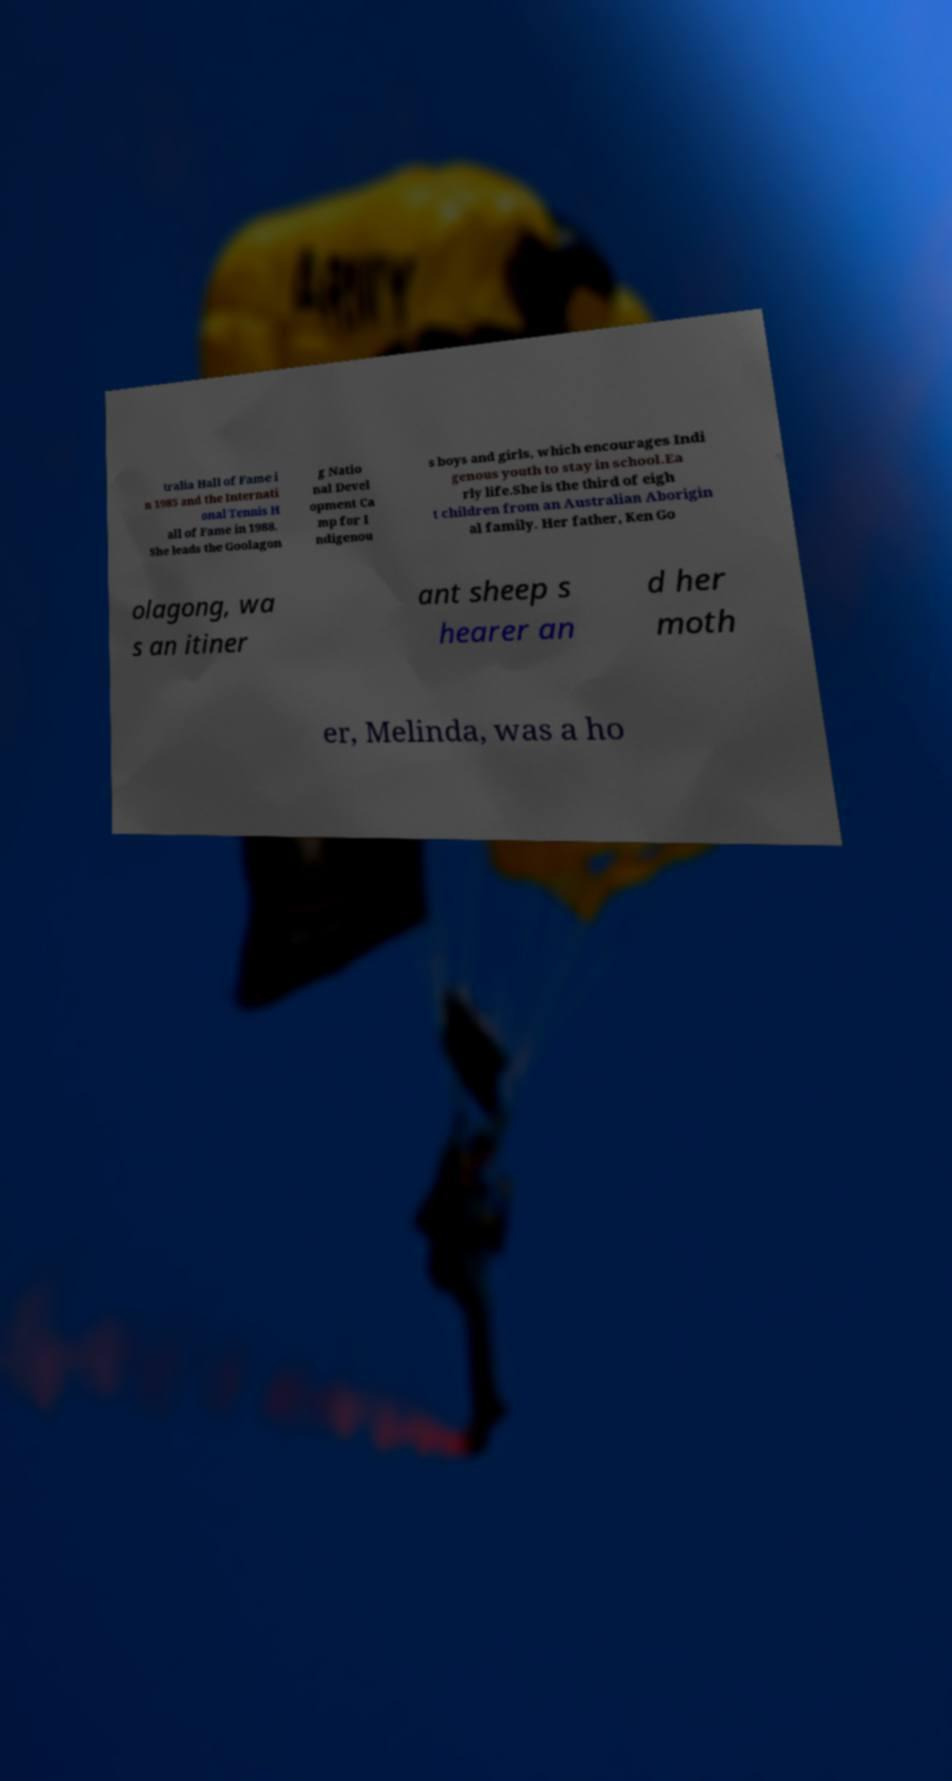Could you assist in decoding the text presented in this image and type it out clearly? tralia Hall of Fame i n 1985 and the Internati onal Tennis H all of Fame in 1988. She leads the Goolagon g Natio nal Devel opment Ca mp for I ndigenou s boys and girls, which encourages Indi genous youth to stay in school.Ea rly life.She is the third of eigh t children from an Australian Aborigin al family. Her father, Ken Go olagong, wa s an itiner ant sheep s hearer an d her moth er, Melinda, was a ho 